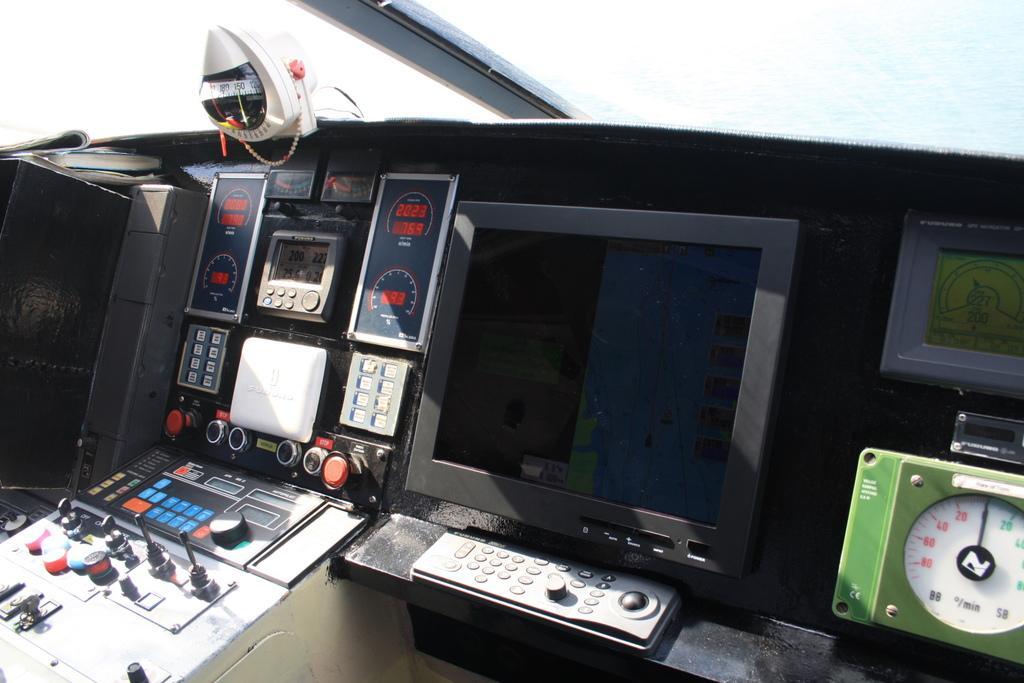Please provide a concise description of this image. In this image I can see a screen and I can also see few machines and I can see white color background. 